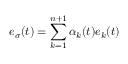<formula> <loc_0><loc_0><loc_500><loc_500>e _ { \sigma } ( t ) = \sum _ { k = 1 } ^ { n + 1 } \alpha _ { k } ( t ) e _ { k } ( t )</formula> 